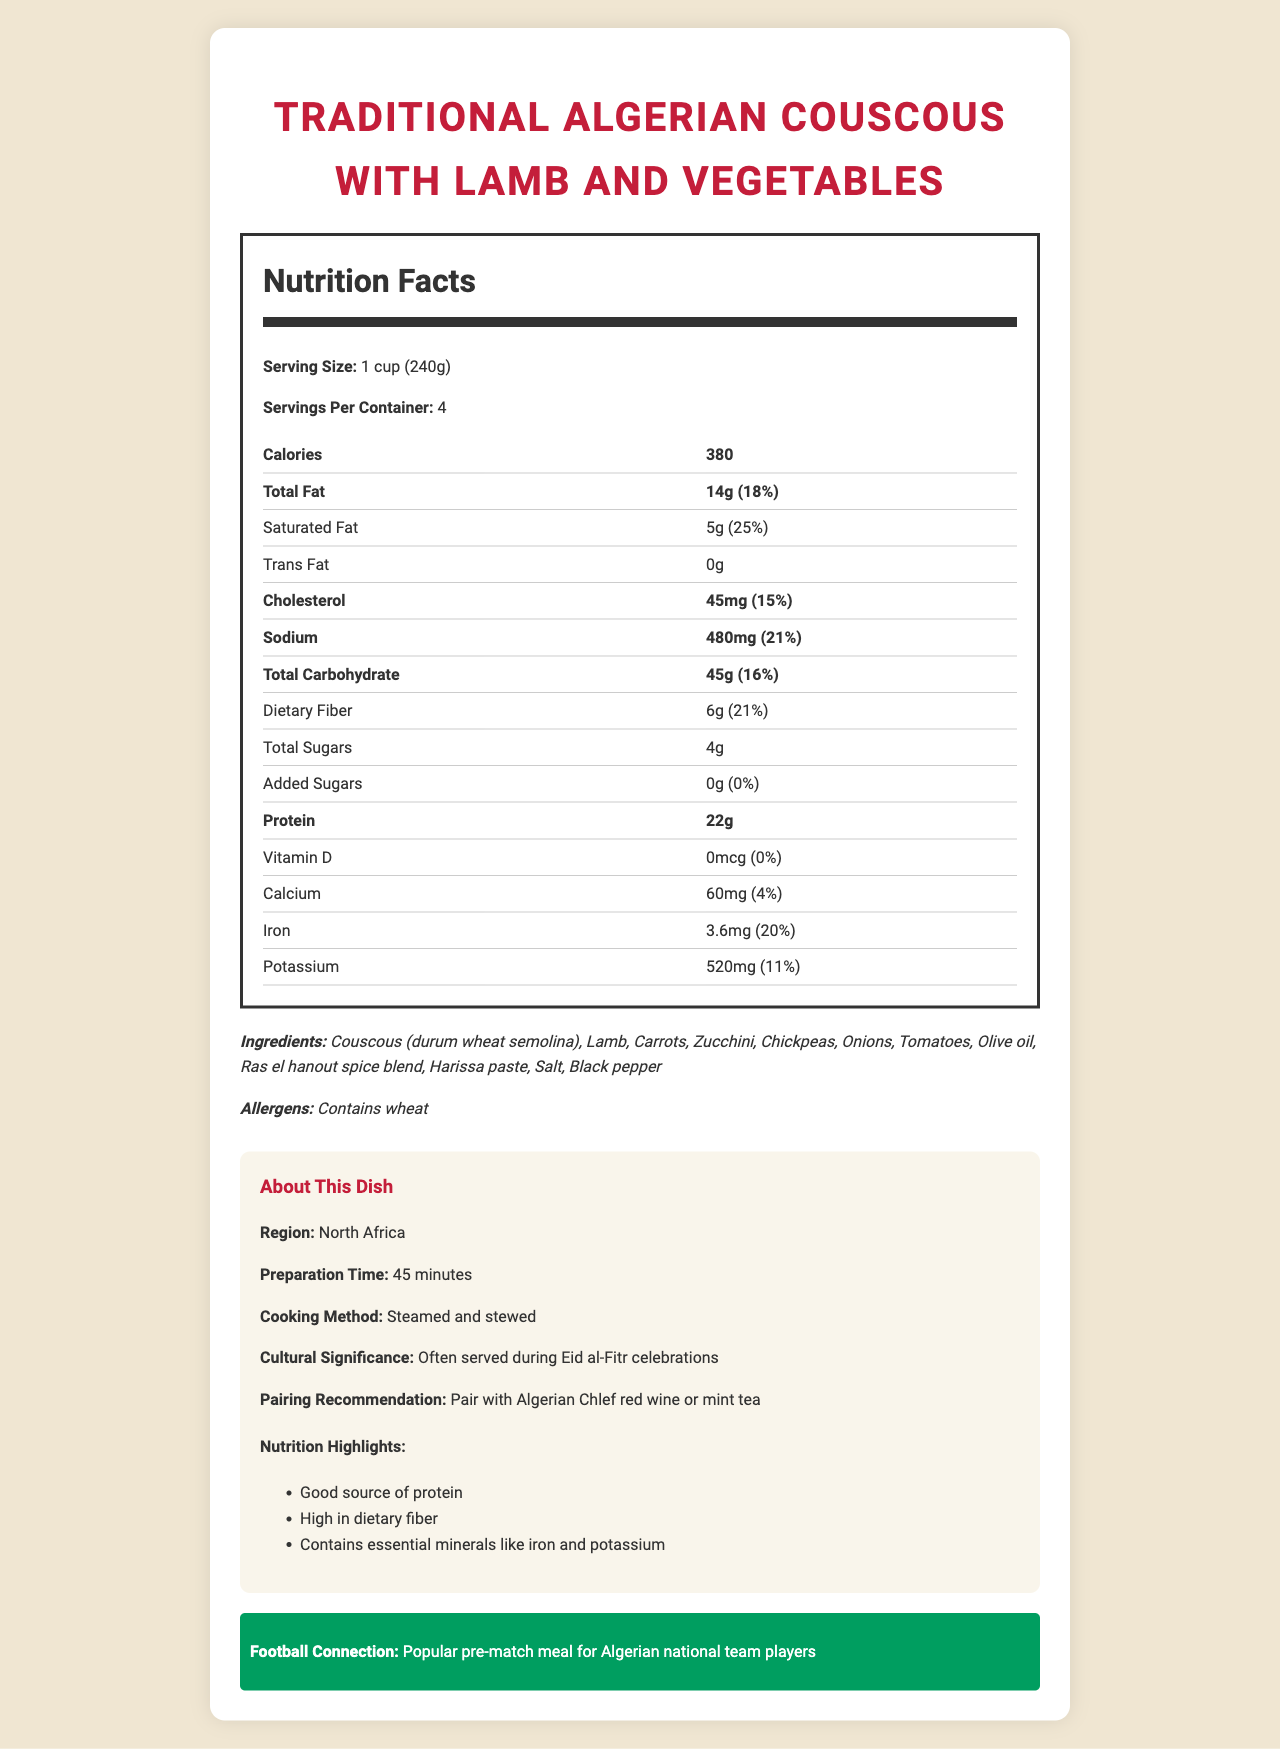what is the serving size of the dish? The serving size is mentioned as "1 cup (240g)" in the Nutrition Facts section.
Answer: 1 cup (240g) how many servings are in the container? The document states that there are 4 servings per container.
Answer: 4 how many calories are in one serving? The document mentions that each serving contains 380 calories.
Answer: 380 which ingredient might cause an allergic reaction? The allergens section specifies that the dish contains wheat.
Answer: Wheat is this dish a good source of protein? The additional info section under "nutrition highlights" mentions that it is a "good source of protein" and each serving contains 22g of protein.
Answer: Yes how much dietary fiber is in one serving? The Nutrition Facts label indicates there are 6g of dietary fiber per serving.
Answer: 6g what percentage of the daily value of saturated fat does one serving contain? The document specifies that each serving contains 5g of saturated fat, which is 25% of the daily value.
Answer: 25% how much potassium is in one serving? A. 480mg B. 520mg C. 600mg D. 620mg The Nutrition Facts section lists 520mg of potassium per serving.
Answer: B. 520mg what is the cooking method for this dish? A. Boiled B. Fried C. Steamed and stewed D. Roasted In the additional info section, the cooking method is described as "Steamed and stewed."
Answer: C. Steamed and stewed does this dish contain any added sugars? The Nutrition Facts label indicates 0g of added sugars.
Answer: No is this dish often served during national celebrations? The document mentions that it is often served during Eid al-Fitr celebrations under the cultural significance section.
Answer: Yes describe the entire document The document provides comprehensive nutritional information, ingredients, and contextual background, making it clear how the dish is prepared and its significance both culturally and nutritionally.
Answer: The document is a detailed Nutrition Facts Label for a traditional Algerian couscous dish with lamb and vegetables. It outlines the serving size, servings per container, and the caloric and nutritional content per serving, including details on fat, cholesterol, sodium, carbohydrates, protein, vitamins, and minerals. Ingredients and allergens are listed, along with additional information about the dish's region, preparation time, cooking method, cultural significance, pairing recommendations, and its connection to football. The dish is highlighted as a good source of protein, high in dietary fiber, and containing essential minerals like iron and potassium. what mineral is present at 20% of the daily value per serving? The Nutrition Facts label shows that each serving contains 3.6mg of iron, which is 20% of the daily value.
Answer: Iron how often is this dish recommended to be paired with mint tea? The document recommends pairing the dish with Algerian Chlef red wine or mint tea, but does not specify how often mint tea should be paired with it.
Answer: Cannot be determined 